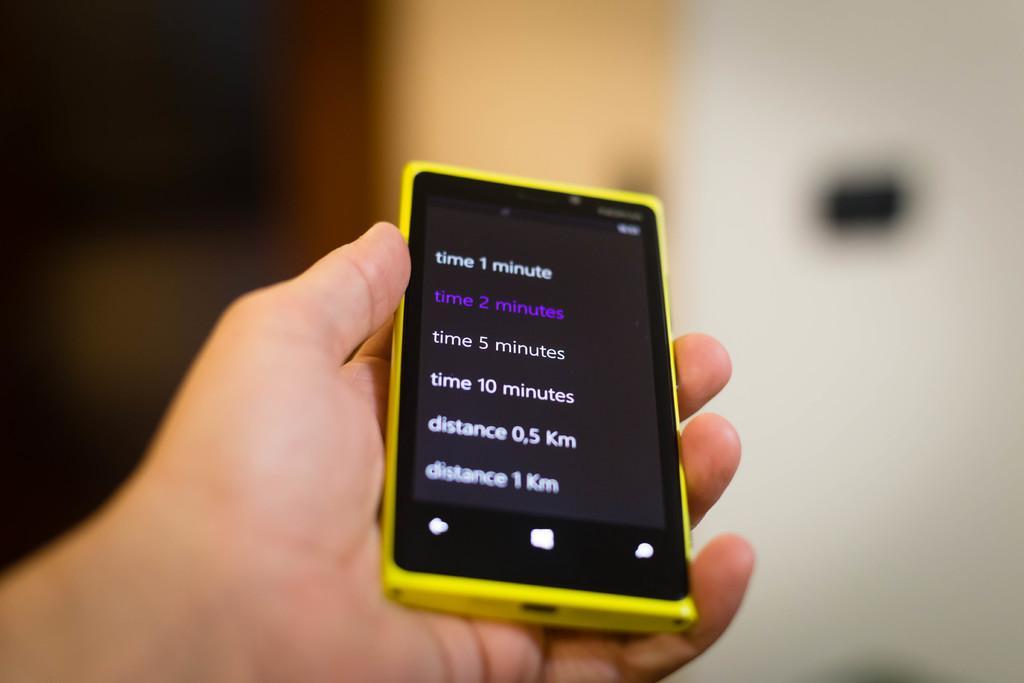Describe this image in one or two sentences. There is a person's hand holding a yellow color mobile. The background is blurred. 